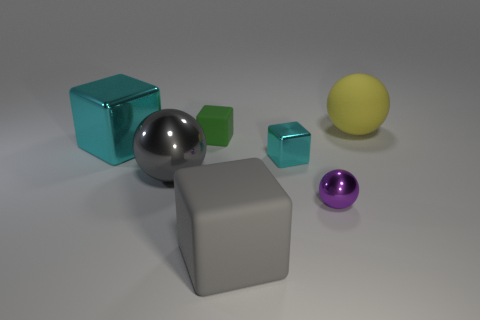Subtract all matte balls. How many balls are left? 2 Subtract all brown cylinders. How many cyan cubes are left? 2 Add 3 purple metal balls. How many objects exist? 10 Subtract 1 blocks. How many blocks are left? 3 Subtract all gray cubes. How many cubes are left? 3 Subtract all spheres. How many objects are left? 4 Add 2 large gray objects. How many large gray objects exist? 4 Subtract 1 purple spheres. How many objects are left? 6 Subtract all cyan spheres. Subtract all yellow cylinders. How many spheres are left? 3 Subtract all yellow balls. Subtract all yellow spheres. How many objects are left? 5 